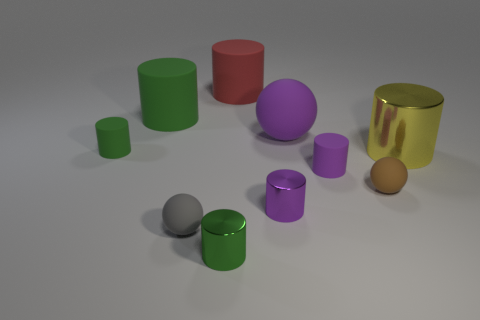What size is the gray sphere that is made of the same material as the large purple object?
Your answer should be very brief. Small. What size is the green shiny thing that is the same shape as the large red object?
Make the answer very short. Small. Are any big purple cylinders visible?
Your response must be concise. No. What number of things are small metal cylinders right of the red object or small yellow shiny cubes?
Keep it short and to the point. 1. There is a yellow thing that is the same size as the red thing; what is it made of?
Give a very brief answer. Metal. What color is the small ball behind the tiny shiny cylinder behind the green metal cylinder?
Your answer should be very brief. Brown. There is a large green cylinder; what number of big spheres are behind it?
Provide a short and direct response. 0. The large ball has what color?
Provide a short and direct response. Purple. How many small things are red metal objects or red rubber cylinders?
Give a very brief answer. 0. Do the metal cylinder to the right of the large purple object and the small rubber object in front of the brown rubber ball have the same color?
Ensure brevity in your answer.  No. 